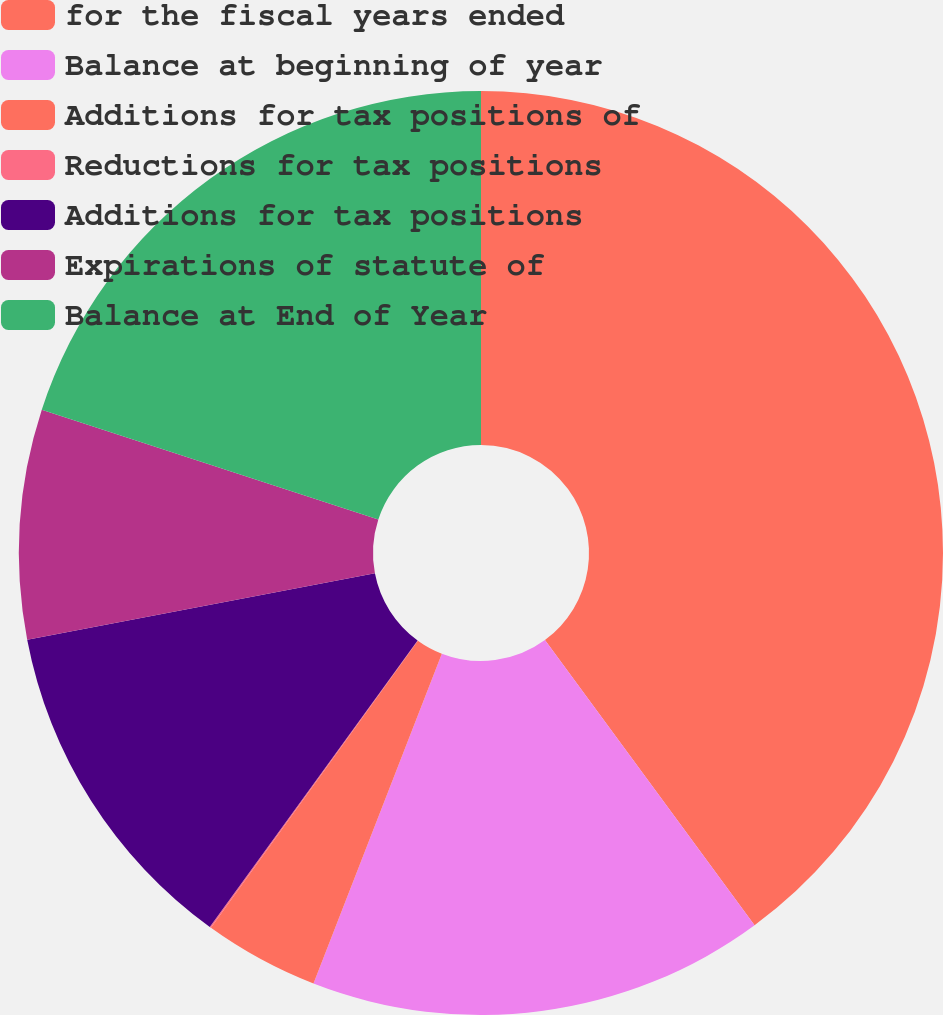Convert chart to OTSL. <chart><loc_0><loc_0><loc_500><loc_500><pie_chart><fcel>for the fiscal years ended<fcel>Balance at beginning of year<fcel>Additions for tax positions of<fcel>Reductions for tax positions<fcel>Additions for tax positions<fcel>Expirations of statute of<fcel>Balance at End of Year<nl><fcel>39.91%<fcel>15.99%<fcel>4.03%<fcel>0.05%<fcel>12.01%<fcel>8.02%<fcel>19.98%<nl></chart> 